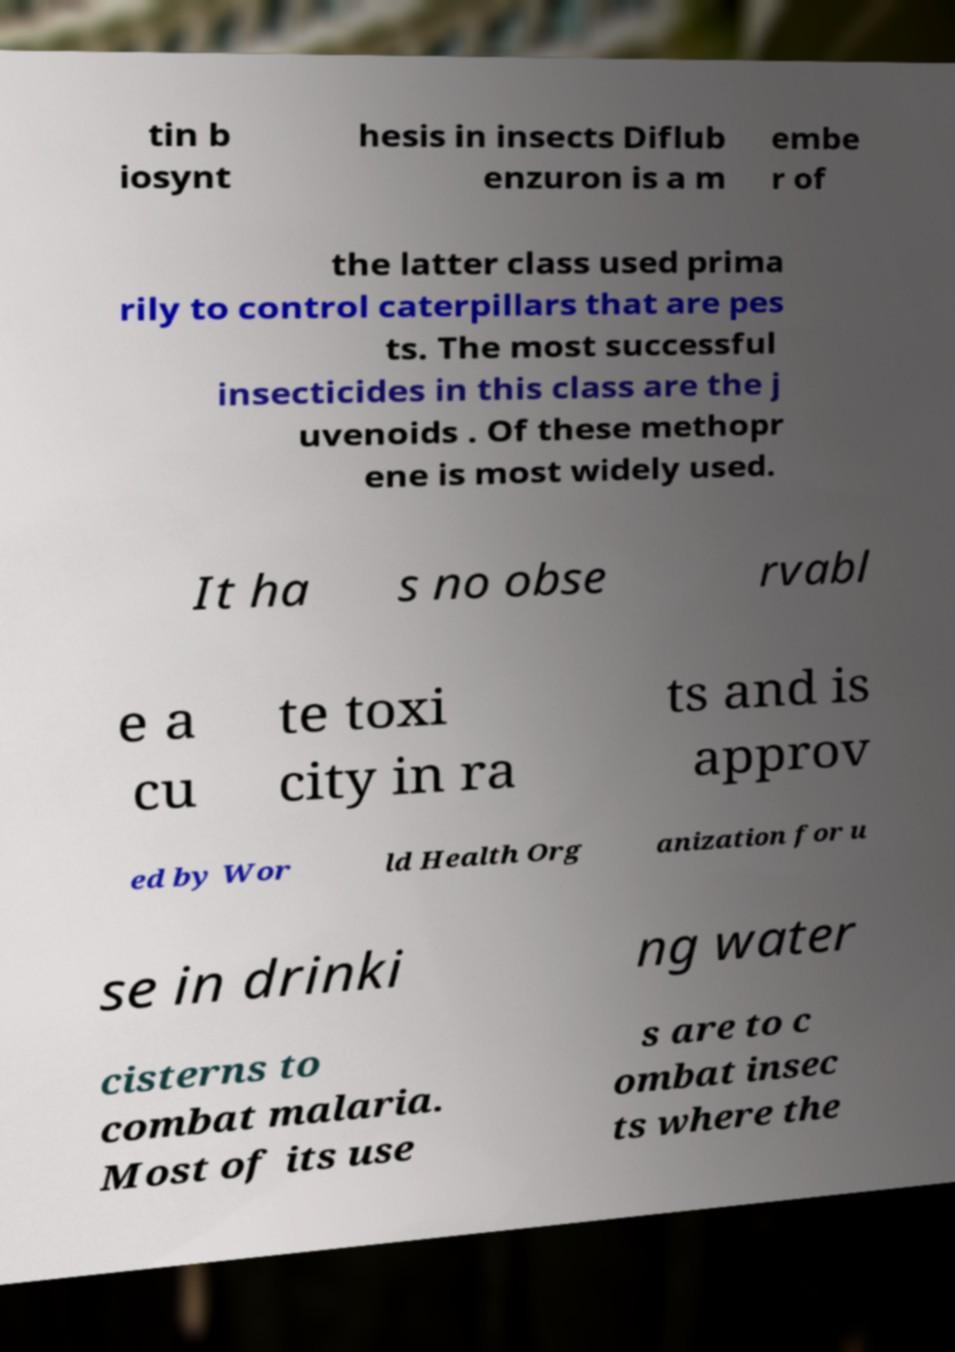Please read and relay the text visible in this image. What does it say? tin b iosynt hesis in insects Diflub enzuron is a m embe r of the latter class used prima rily to control caterpillars that are pes ts. The most successful insecticides in this class are the j uvenoids . Of these methopr ene is most widely used. It ha s no obse rvabl e a cu te toxi city in ra ts and is approv ed by Wor ld Health Org anization for u se in drinki ng water cisterns to combat malaria. Most of its use s are to c ombat insec ts where the 